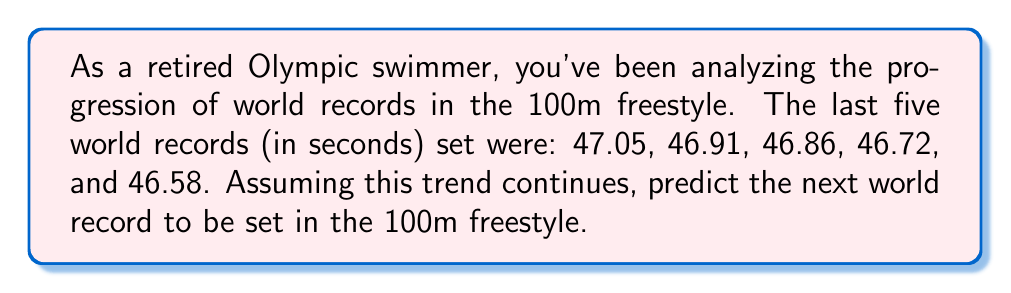Help me with this question. Let's approach this step-by-step:

1) First, we need to calculate the differences between each consecutive world record:
   47.05 - 46.91 = 0.14
   46.91 - 46.86 = 0.05
   46.86 - 46.72 = 0.14
   46.72 - 46.58 = 0.14

2) We can see that the improvement is not constant, but there's a pattern. Three out of four differences are 0.14 seconds.

3) Let's calculate the average improvement:
   $\frac{0.14 + 0.05 + 0.14 + 0.14}{4} = \frac{0.47}{4} = 0.1175$ seconds

4) Rounding to the nearest hundredth (as swim times are typically measured), we get 0.12 seconds as the average improvement.

5) To predict the next world record, we subtract this average improvement from the last record:
   46.58 - 0.12 = 46.46

6) As a former swimmer, you know that world records are typically recorded to the nearest hundredth of a second, so we should round our answer to 46.46 seconds.
Answer: 46.46 seconds 